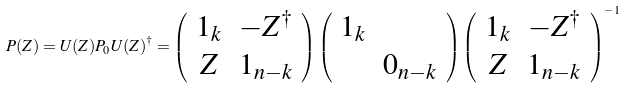Convert formula to latex. <formula><loc_0><loc_0><loc_500><loc_500>P ( Z ) = U ( Z ) P _ { 0 } U ( Z ) ^ { \dagger } = \left ( \begin{array} { c c } 1 _ { k } & - Z ^ { \dagger } \\ Z & 1 _ { n - k } \end{array} \right ) \left ( \begin{array} { c c } 1 _ { k } & \\ & 0 _ { n - k } \end{array} \right ) \left ( \begin{array} { c c } 1 _ { k } & - Z ^ { \dagger } \\ Z & 1 _ { n - k } \end{array} \right ) ^ { - 1 }</formula> 